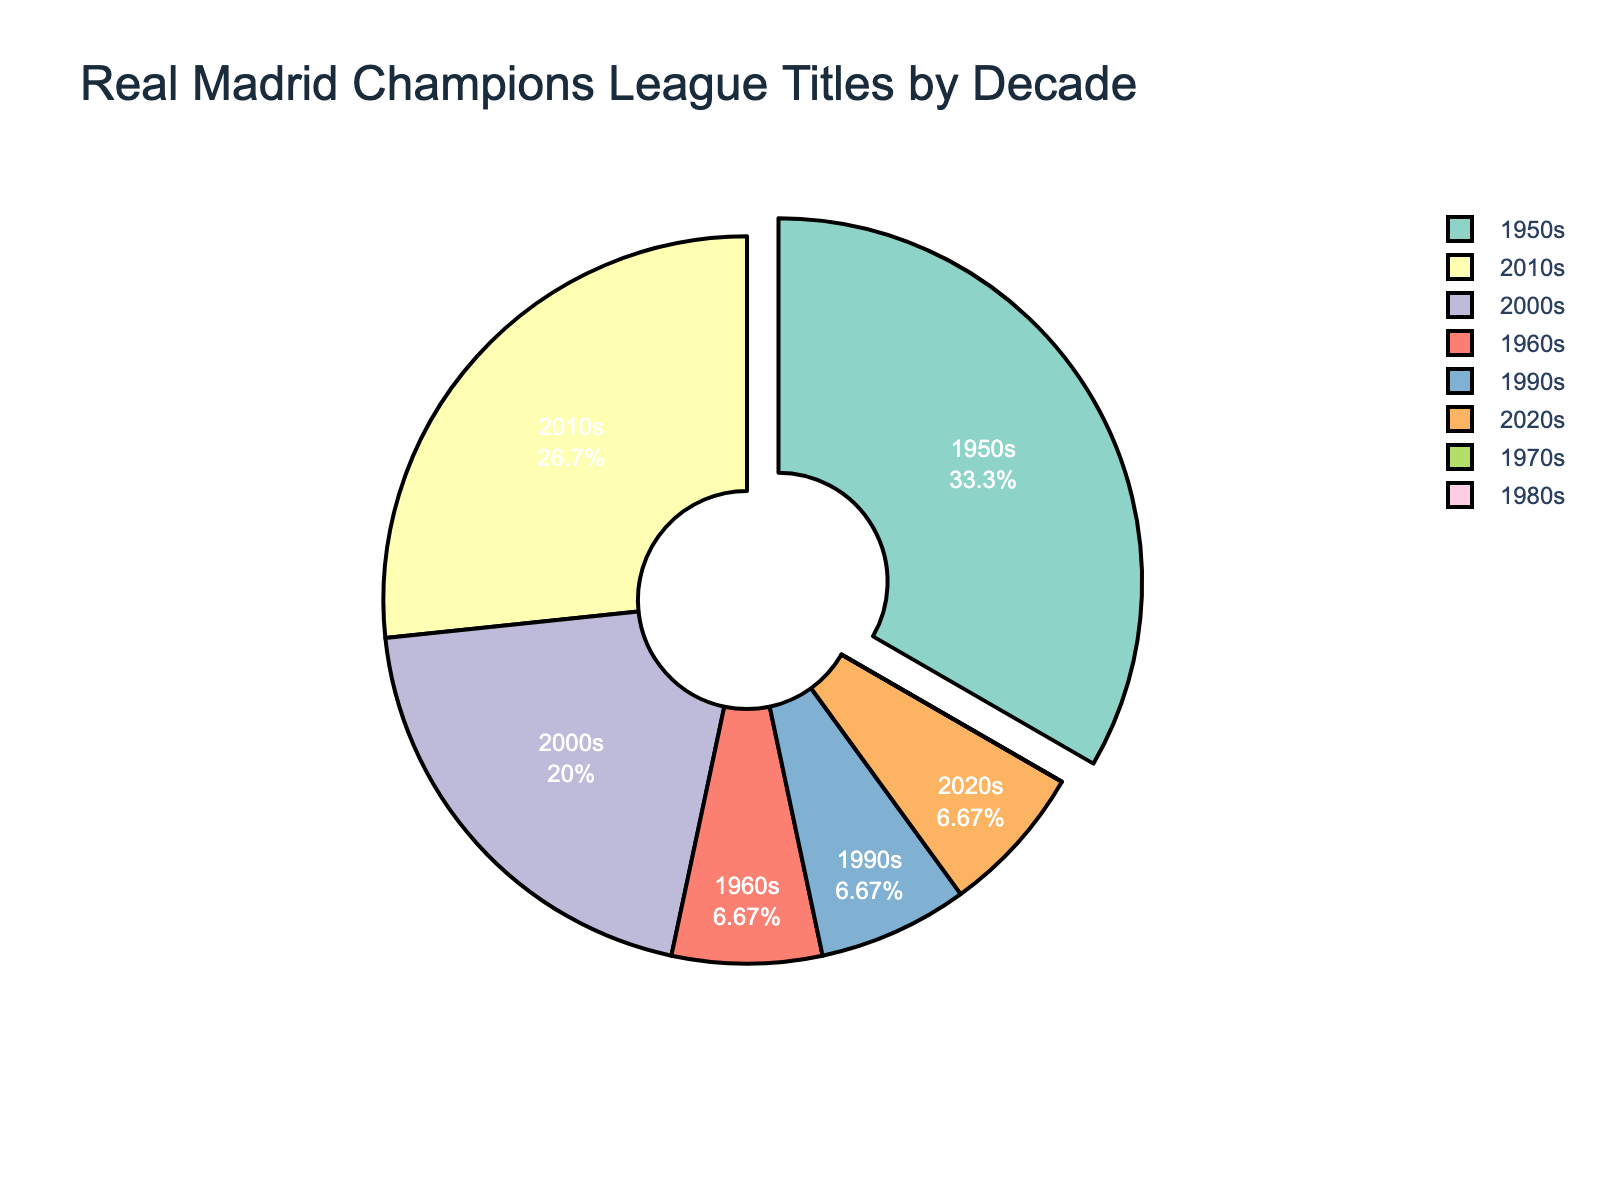Which decade has the highest number of Champions League titles for Real Madrid? By observing the pie chart, the 1950s segment has the largest proportion among all the decades. Therefore, the 1950s decade has the highest number of Champions League titles with 5 titles.
Answer: 1950s How many Champions League titles did Real Madrid win in the 2000s and 2010s combined? The pie chart shows that Real Madrid won 3 titles in the 2000s and 4 titles in the 2010s. Adding these together gives 3 + 4 = 7 titles.
Answer: 7 Which decades have the same number of Champions League titles? The pie chart shows that the 1960s, 1990s, and 2020s each have 1 title. Additionally, the 1970s and 1980s both show 0 titles. Therefore, these pairs of decades have the same number of titles.
Answer: 1960s, 1990s, 2020s; 1970s, 1980s What is the total number of Champions League titles won by Real Madrid from the 1950s through the 2010s? We add the titles from each decade: 5 (1950s) + 1 (1960s) + 0 (1970s) + 0 (1980s) + 1 (1990s) + 3 (2000s) + 4 (2010s) = 14 titles.
Answer: 14 Which decade has the smallest proportion of Champions League titles for Real Madrid? The pie chart reveals that the 1970s and 1980s segments are the smallest, indicating 0 titles in each decade. Either answer is acceptable, but commonly the 1970s might be chosen.
Answer: 1970s Is the combined total of titles in the 2000s and 2010s greater than the total number of titles in the 1950s? The 2000s and 2010s together have 3 + 4 = 7 titles, while the 1950s has 5 titles. Since 7 is greater than 5, the combined total of the 2000s and 2010s is indeed greater.
Answer: Yes How many more titles did Real Madrid win in the 2010s than in the 1990s? According to the pie chart, Real Madrid won 4 titles in the 2010s and 1 title in the 1990s. The difference is 4 - 1 = 3 titles.
Answer: 3 What percentage of Real Madrid's total Champions League titles were won in the 1950s? From the pie chart, Real Madrid has a total of 5 (1950s) + 1 (1960s) + 0 (1970s) + 0 (1980s) + 1 (1990s) + 3 (2000s) + 4 (2010s) + 1 (2020s) = 15 titles. The percentage is calculated as (5 / 15) * 100 = 33.33%.
Answer: 33.33% 